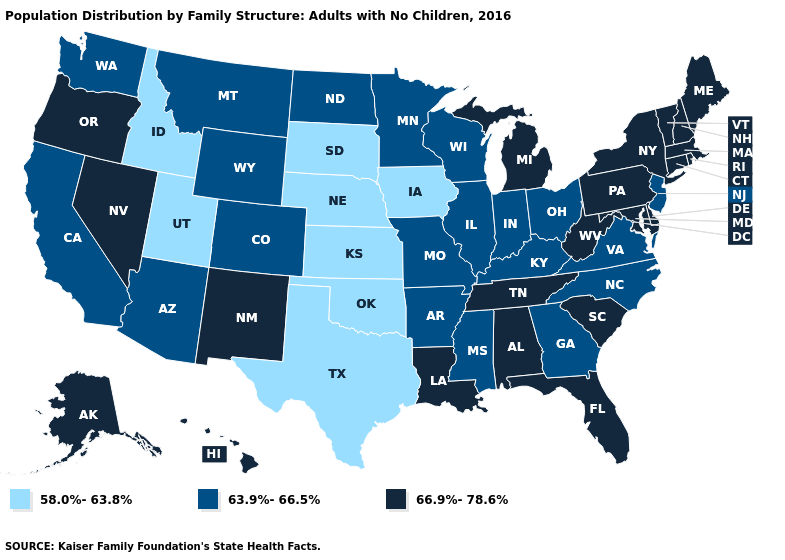Does New Hampshire have a higher value than North Carolina?
Give a very brief answer. Yes. Which states have the lowest value in the West?
Quick response, please. Idaho, Utah. What is the value of Utah?
Quick response, please. 58.0%-63.8%. What is the value of Maryland?
Quick response, please. 66.9%-78.6%. What is the value of Arizona?
Write a very short answer. 63.9%-66.5%. Does Florida have the same value as Rhode Island?
Be succinct. Yes. What is the value of Texas?
Concise answer only. 58.0%-63.8%. Does the first symbol in the legend represent the smallest category?
Give a very brief answer. Yes. What is the highest value in the USA?
Be succinct. 66.9%-78.6%. Which states have the lowest value in the South?
Short answer required. Oklahoma, Texas. What is the lowest value in the Northeast?
Be succinct. 63.9%-66.5%. Does the first symbol in the legend represent the smallest category?
Quick response, please. Yes. Name the states that have a value in the range 66.9%-78.6%?
Be succinct. Alabama, Alaska, Connecticut, Delaware, Florida, Hawaii, Louisiana, Maine, Maryland, Massachusetts, Michigan, Nevada, New Hampshire, New Mexico, New York, Oregon, Pennsylvania, Rhode Island, South Carolina, Tennessee, Vermont, West Virginia. Which states have the highest value in the USA?
Keep it brief. Alabama, Alaska, Connecticut, Delaware, Florida, Hawaii, Louisiana, Maine, Maryland, Massachusetts, Michigan, Nevada, New Hampshire, New Mexico, New York, Oregon, Pennsylvania, Rhode Island, South Carolina, Tennessee, Vermont, West Virginia. Among the states that border Louisiana , does Texas have the lowest value?
Short answer required. Yes. 